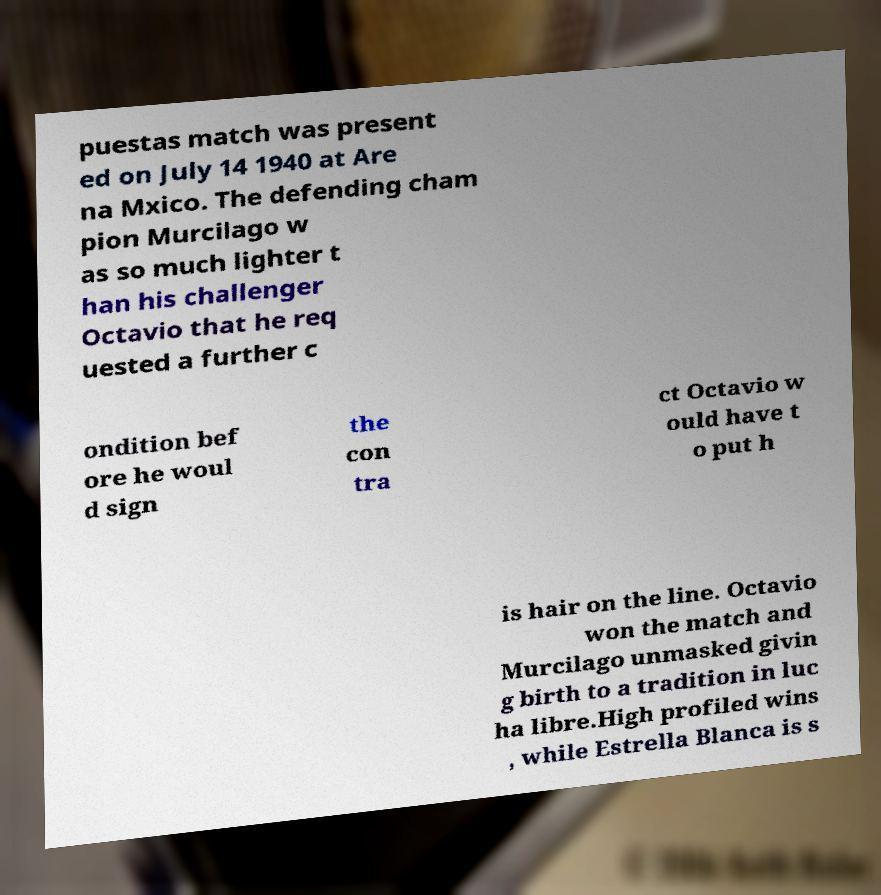What messages or text are displayed in this image? I need them in a readable, typed format. puestas match was present ed on July 14 1940 at Are na Mxico. The defending cham pion Murcilago w as so much lighter t han his challenger Octavio that he req uested a further c ondition bef ore he woul d sign the con tra ct Octavio w ould have t o put h is hair on the line. Octavio won the match and Murcilago unmasked givin g birth to a tradition in luc ha libre.High profiled wins , while Estrella Blanca is s 